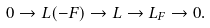Convert formula to latex. <formula><loc_0><loc_0><loc_500><loc_500>0 \to L ( - F ) \to L \to L _ { F } \to 0 .</formula> 